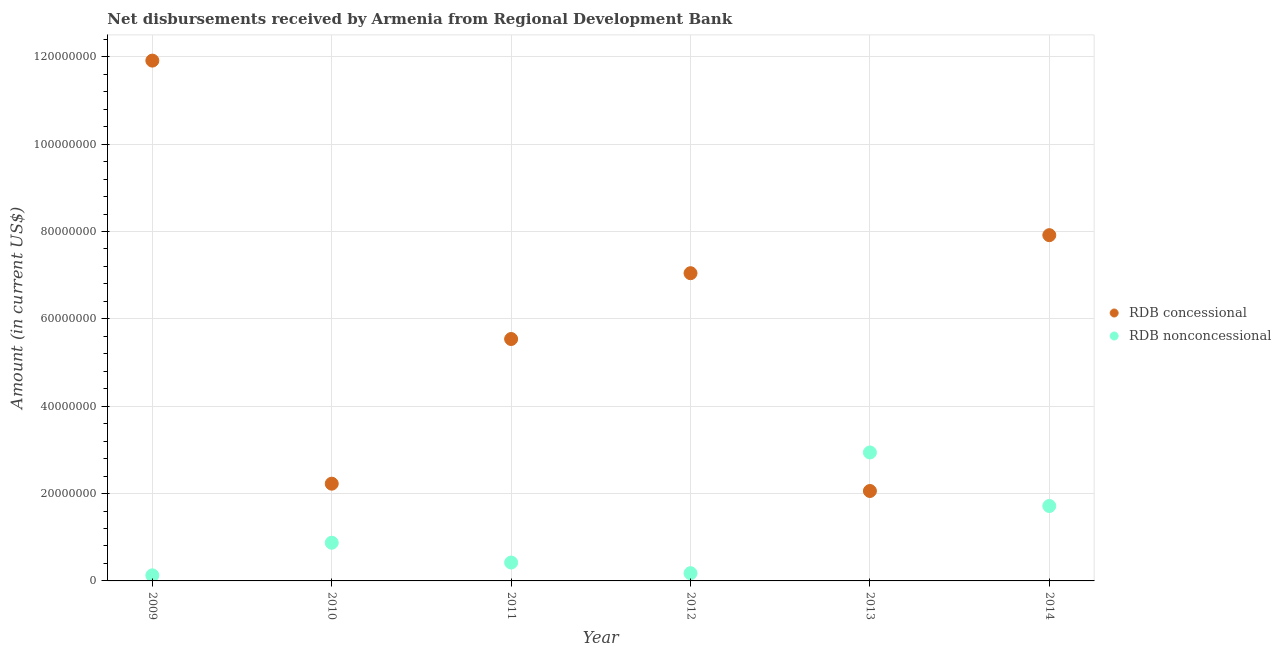How many different coloured dotlines are there?
Your response must be concise. 2. Is the number of dotlines equal to the number of legend labels?
Your answer should be very brief. Yes. What is the net non concessional disbursements from rdb in 2009?
Give a very brief answer. 1.28e+06. Across all years, what is the maximum net non concessional disbursements from rdb?
Ensure brevity in your answer.  2.94e+07. Across all years, what is the minimum net non concessional disbursements from rdb?
Your response must be concise. 1.28e+06. In which year was the net non concessional disbursements from rdb maximum?
Offer a very short reply. 2013. What is the total net non concessional disbursements from rdb in the graph?
Your answer should be very brief. 6.26e+07. What is the difference between the net non concessional disbursements from rdb in 2013 and that in 2014?
Provide a succinct answer. 1.23e+07. What is the difference between the net concessional disbursements from rdb in 2014 and the net non concessional disbursements from rdb in 2013?
Ensure brevity in your answer.  4.98e+07. What is the average net non concessional disbursements from rdb per year?
Provide a short and direct response. 1.04e+07. In the year 2013, what is the difference between the net non concessional disbursements from rdb and net concessional disbursements from rdb?
Give a very brief answer. 8.82e+06. In how many years, is the net concessional disbursements from rdb greater than 40000000 US$?
Provide a short and direct response. 4. What is the ratio of the net non concessional disbursements from rdb in 2009 to that in 2010?
Give a very brief answer. 0.15. Is the net concessional disbursements from rdb in 2013 less than that in 2014?
Offer a terse response. Yes. Is the difference between the net concessional disbursements from rdb in 2011 and 2012 greater than the difference between the net non concessional disbursements from rdb in 2011 and 2012?
Offer a terse response. No. What is the difference between the highest and the second highest net concessional disbursements from rdb?
Offer a very short reply. 4.00e+07. What is the difference between the highest and the lowest net concessional disbursements from rdb?
Make the answer very short. 9.85e+07. In how many years, is the net concessional disbursements from rdb greater than the average net concessional disbursements from rdb taken over all years?
Give a very brief answer. 3. Does the net concessional disbursements from rdb monotonically increase over the years?
Ensure brevity in your answer.  No. Does the graph contain grids?
Provide a short and direct response. Yes. Where does the legend appear in the graph?
Provide a short and direct response. Center right. How many legend labels are there?
Offer a terse response. 2. How are the legend labels stacked?
Ensure brevity in your answer.  Vertical. What is the title of the graph?
Provide a succinct answer. Net disbursements received by Armenia from Regional Development Bank. What is the label or title of the Y-axis?
Your response must be concise. Amount (in current US$). What is the Amount (in current US$) in RDB concessional in 2009?
Ensure brevity in your answer.  1.19e+08. What is the Amount (in current US$) in RDB nonconcessional in 2009?
Provide a succinct answer. 1.28e+06. What is the Amount (in current US$) in RDB concessional in 2010?
Keep it short and to the point. 2.23e+07. What is the Amount (in current US$) of RDB nonconcessional in 2010?
Offer a very short reply. 8.75e+06. What is the Amount (in current US$) of RDB concessional in 2011?
Provide a succinct answer. 5.54e+07. What is the Amount (in current US$) of RDB nonconcessional in 2011?
Provide a succinct answer. 4.21e+06. What is the Amount (in current US$) of RDB concessional in 2012?
Keep it short and to the point. 7.05e+07. What is the Amount (in current US$) in RDB nonconcessional in 2012?
Your answer should be very brief. 1.77e+06. What is the Amount (in current US$) in RDB concessional in 2013?
Provide a short and direct response. 2.06e+07. What is the Amount (in current US$) of RDB nonconcessional in 2013?
Provide a short and direct response. 2.94e+07. What is the Amount (in current US$) in RDB concessional in 2014?
Ensure brevity in your answer.  7.92e+07. What is the Amount (in current US$) in RDB nonconcessional in 2014?
Give a very brief answer. 1.72e+07. Across all years, what is the maximum Amount (in current US$) in RDB concessional?
Your answer should be compact. 1.19e+08. Across all years, what is the maximum Amount (in current US$) of RDB nonconcessional?
Provide a succinct answer. 2.94e+07. Across all years, what is the minimum Amount (in current US$) in RDB concessional?
Give a very brief answer. 2.06e+07. Across all years, what is the minimum Amount (in current US$) in RDB nonconcessional?
Your response must be concise. 1.28e+06. What is the total Amount (in current US$) of RDB concessional in the graph?
Give a very brief answer. 3.67e+08. What is the total Amount (in current US$) in RDB nonconcessional in the graph?
Ensure brevity in your answer.  6.26e+07. What is the difference between the Amount (in current US$) of RDB concessional in 2009 and that in 2010?
Provide a succinct answer. 9.69e+07. What is the difference between the Amount (in current US$) in RDB nonconcessional in 2009 and that in 2010?
Keep it short and to the point. -7.47e+06. What is the difference between the Amount (in current US$) in RDB concessional in 2009 and that in 2011?
Offer a terse response. 6.37e+07. What is the difference between the Amount (in current US$) of RDB nonconcessional in 2009 and that in 2011?
Keep it short and to the point. -2.93e+06. What is the difference between the Amount (in current US$) of RDB concessional in 2009 and that in 2012?
Provide a succinct answer. 4.87e+07. What is the difference between the Amount (in current US$) of RDB nonconcessional in 2009 and that in 2012?
Keep it short and to the point. -4.95e+05. What is the difference between the Amount (in current US$) of RDB concessional in 2009 and that in 2013?
Your answer should be compact. 9.85e+07. What is the difference between the Amount (in current US$) of RDB nonconcessional in 2009 and that in 2013?
Provide a succinct answer. -2.81e+07. What is the difference between the Amount (in current US$) in RDB concessional in 2009 and that in 2014?
Give a very brief answer. 4.00e+07. What is the difference between the Amount (in current US$) of RDB nonconcessional in 2009 and that in 2014?
Provide a succinct answer. -1.59e+07. What is the difference between the Amount (in current US$) in RDB concessional in 2010 and that in 2011?
Your response must be concise. -3.31e+07. What is the difference between the Amount (in current US$) in RDB nonconcessional in 2010 and that in 2011?
Ensure brevity in your answer.  4.54e+06. What is the difference between the Amount (in current US$) of RDB concessional in 2010 and that in 2012?
Keep it short and to the point. -4.82e+07. What is the difference between the Amount (in current US$) of RDB nonconcessional in 2010 and that in 2012?
Your response must be concise. 6.98e+06. What is the difference between the Amount (in current US$) in RDB concessional in 2010 and that in 2013?
Offer a terse response. 1.67e+06. What is the difference between the Amount (in current US$) in RDB nonconcessional in 2010 and that in 2013?
Offer a very short reply. -2.07e+07. What is the difference between the Amount (in current US$) of RDB concessional in 2010 and that in 2014?
Your answer should be very brief. -5.69e+07. What is the difference between the Amount (in current US$) of RDB nonconcessional in 2010 and that in 2014?
Ensure brevity in your answer.  -8.41e+06. What is the difference between the Amount (in current US$) of RDB concessional in 2011 and that in 2012?
Your answer should be very brief. -1.51e+07. What is the difference between the Amount (in current US$) in RDB nonconcessional in 2011 and that in 2012?
Your answer should be compact. 2.44e+06. What is the difference between the Amount (in current US$) of RDB concessional in 2011 and that in 2013?
Your response must be concise. 3.48e+07. What is the difference between the Amount (in current US$) of RDB nonconcessional in 2011 and that in 2013?
Offer a very short reply. -2.52e+07. What is the difference between the Amount (in current US$) in RDB concessional in 2011 and that in 2014?
Offer a very short reply. -2.38e+07. What is the difference between the Amount (in current US$) of RDB nonconcessional in 2011 and that in 2014?
Your answer should be compact. -1.29e+07. What is the difference between the Amount (in current US$) of RDB concessional in 2012 and that in 2013?
Your answer should be compact. 4.99e+07. What is the difference between the Amount (in current US$) of RDB nonconcessional in 2012 and that in 2013?
Give a very brief answer. -2.76e+07. What is the difference between the Amount (in current US$) in RDB concessional in 2012 and that in 2014?
Keep it short and to the point. -8.71e+06. What is the difference between the Amount (in current US$) in RDB nonconcessional in 2012 and that in 2014?
Provide a succinct answer. -1.54e+07. What is the difference between the Amount (in current US$) of RDB concessional in 2013 and that in 2014?
Your answer should be very brief. -5.86e+07. What is the difference between the Amount (in current US$) of RDB nonconcessional in 2013 and that in 2014?
Offer a very short reply. 1.23e+07. What is the difference between the Amount (in current US$) of RDB concessional in 2009 and the Amount (in current US$) of RDB nonconcessional in 2010?
Provide a short and direct response. 1.10e+08. What is the difference between the Amount (in current US$) in RDB concessional in 2009 and the Amount (in current US$) in RDB nonconcessional in 2011?
Your response must be concise. 1.15e+08. What is the difference between the Amount (in current US$) of RDB concessional in 2009 and the Amount (in current US$) of RDB nonconcessional in 2012?
Keep it short and to the point. 1.17e+08. What is the difference between the Amount (in current US$) of RDB concessional in 2009 and the Amount (in current US$) of RDB nonconcessional in 2013?
Ensure brevity in your answer.  8.97e+07. What is the difference between the Amount (in current US$) of RDB concessional in 2009 and the Amount (in current US$) of RDB nonconcessional in 2014?
Give a very brief answer. 1.02e+08. What is the difference between the Amount (in current US$) in RDB concessional in 2010 and the Amount (in current US$) in RDB nonconcessional in 2011?
Offer a very short reply. 1.81e+07. What is the difference between the Amount (in current US$) of RDB concessional in 2010 and the Amount (in current US$) of RDB nonconcessional in 2012?
Your response must be concise. 2.05e+07. What is the difference between the Amount (in current US$) in RDB concessional in 2010 and the Amount (in current US$) in RDB nonconcessional in 2013?
Offer a very short reply. -7.15e+06. What is the difference between the Amount (in current US$) of RDB concessional in 2010 and the Amount (in current US$) of RDB nonconcessional in 2014?
Make the answer very short. 5.11e+06. What is the difference between the Amount (in current US$) in RDB concessional in 2011 and the Amount (in current US$) in RDB nonconcessional in 2012?
Provide a succinct answer. 5.36e+07. What is the difference between the Amount (in current US$) in RDB concessional in 2011 and the Amount (in current US$) in RDB nonconcessional in 2013?
Offer a very short reply. 2.60e+07. What is the difference between the Amount (in current US$) of RDB concessional in 2011 and the Amount (in current US$) of RDB nonconcessional in 2014?
Give a very brief answer. 3.82e+07. What is the difference between the Amount (in current US$) in RDB concessional in 2012 and the Amount (in current US$) in RDB nonconcessional in 2013?
Provide a short and direct response. 4.10e+07. What is the difference between the Amount (in current US$) in RDB concessional in 2012 and the Amount (in current US$) in RDB nonconcessional in 2014?
Make the answer very short. 5.33e+07. What is the difference between the Amount (in current US$) of RDB concessional in 2013 and the Amount (in current US$) of RDB nonconcessional in 2014?
Offer a very short reply. 3.44e+06. What is the average Amount (in current US$) of RDB concessional per year?
Your answer should be very brief. 6.12e+07. What is the average Amount (in current US$) in RDB nonconcessional per year?
Your response must be concise. 1.04e+07. In the year 2009, what is the difference between the Amount (in current US$) in RDB concessional and Amount (in current US$) in RDB nonconcessional?
Make the answer very short. 1.18e+08. In the year 2010, what is the difference between the Amount (in current US$) of RDB concessional and Amount (in current US$) of RDB nonconcessional?
Offer a very short reply. 1.35e+07. In the year 2011, what is the difference between the Amount (in current US$) in RDB concessional and Amount (in current US$) in RDB nonconcessional?
Your response must be concise. 5.12e+07. In the year 2012, what is the difference between the Amount (in current US$) in RDB concessional and Amount (in current US$) in RDB nonconcessional?
Your answer should be very brief. 6.87e+07. In the year 2013, what is the difference between the Amount (in current US$) in RDB concessional and Amount (in current US$) in RDB nonconcessional?
Ensure brevity in your answer.  -8.82e+06. In the year 2014, what is the difference between the Amount (in current US$) in RDB concessional and Amount (in current US$) in RDB nonconcessional?
Offer a very short reply. 6.20e+07. What is the ratio of the Amount (in current US$) of RDB concessional in 2009 to that in 2010?
Your answer should be very brief. 5.35. What is the ratio of the Amount (in current US$) of RDB nonconcessional in 2009 to that in 2010?
Provide a succinct answer. 0.15. What is the ratio of the Amount (in current US$) in RDB concessional in 2009 to that in 2011?
Offer a very short reply. 2.15. What is the ratio of the Amount (in current US$) of RDB nonconcessional in 2009 to that in 2011?
Provide a short and direct response. 0.3. What is the ratio of the Amount (in current US$) of RDB concessional in 2009 to that in 2012?
Your response must be concise. 1.69. What is the ratio of the Amount (in current US$) of RDB nonconcessional in 2009 to that in 2012?
Ensure brevity in your answer.  0.72. What is the ratio of the Amount (in current US$) in RDB concessional in 2009 to that in 2013?
Keep it short and to the point. 5.79. What is the ratio of the Amount (in current US$) in RDB nonconcessional in 2009 to that in 2013?
Provide a short and direct response. 0.04. What is the ratio of the Amount (in current US$) in RDB concessional in 2009 to that in 2014?
Your answer should be compact. 1.5. What is the ratio of the Amount (in current US$) of RDB nonconcessional in 2009 to that in 2014?
Your answer should be compact. 0.07. What is the ratio of the Amount (in current US$) of RDB concessional in 2010 to that in 2011?
Give a very brief answer. 0.4. What is the ratio of the Amount (in current US$) of RDB nonconcessional in 2010 to that in 2011?
Ensure brevity in your answer.  2.08. What is the ratio of the Amount (in current US$) in RDB concessional in 2010 to that in 2012?
Ensure brevity in your answer.  0.32. What is the ratio of the Amount (in current US$) in RDB nonconcessional in 2010 to that in 2012?
Provide a short and direct response. 4.94. What is the ratio of the Amount (in current US$) in RDB concessional in 2010 to that in 2013?
Give a very brief answer. 1.08. What is the ratio of the Amount (in current US$) in RDB nonconcessional in 2010 to that in 2013?
Provide a succinct answer. 0.3. What is the ratio of the Amount (in current US$) of RDB concessional in 2010 to that in 2014?
Provide a short and direct response. 0.28. What is the ratio of the Amount (in current US$) in RDB nonconcessional in 2010 to that in 2014?
Your answer should be very brief. 0.51. What is the ratio of the Amount (in current US$) in RDB concessional in 2011 to that in 2012?
Give a very brief answer. 0.79. What is the ratio of the Amount (in current US$) in RDB nonconcessional in 2011 to that in 2012?
Ensure brevity in your answer.  2.38. What is the ratio of the Amount (in current US$) of RDB concessional in 2011 to that in 2013?
Your response must be concise. 2.69. What is the ratio of the Amount (in current US$) of RDB nonconcessional in 2011 to that in 2013?
Your response must be concise. 0.14. What is the ratio of the Amount (in current US$) of RDB concessional in 2011 to that in 2014?
Offer a terse response. 0.7. What is the ratio of the Amount (in current US$) in RDB nonconcessional in 2011 to that in 2014?
Offer a very short reply. 0.25. What is the ratio of the Amount (in current US$) of RDB concessional in 2012 to that in 2013?
Keep it short and to the point. 3.42. What is the ratio of the Amount (in current US$) of RDB nonconcessional in 2012 to that in 2013?
Give a very brief answer. 0.06. What is the ratio of the Amount (in current US$) in RDB concessional in 2012 to that in 2014?
Provide a short and direct response. 0.89. What is the ratio of the Amount (in current US$) in RDB nonconcessional in 2012 to that in 2014?
Give a very brief answer. 0.1. What is the ratio of the Amount (in current US$) in RDB concessional in 2013 to that in 2014?
Ensure brevity in your answer.  0.26. What is the ratio of the Amount (in current US$) in RDB nonconcessional in 2013 to that in 2014?
Give a very brief answer. 1.71. What is the difference between the highest and the second highest Amount (in current US$) of RDB concessional?
Your answer should be very brief. 4.00e+07. What is the difference between the highest and the second highest Amount (in current US$) of RDB nonconcessional?
Provide a short and direct response. 1.23e+07. What is the difference between the highest and the lowest Amount (in current US$) of RDB concessional?
Ensure brevity in your answer.  9.85e+07. What is the difference between the highest and the lowest Amount (in current US$) in RDB nonconcessional?
Keep it short and to the point. 2.81e+07. 